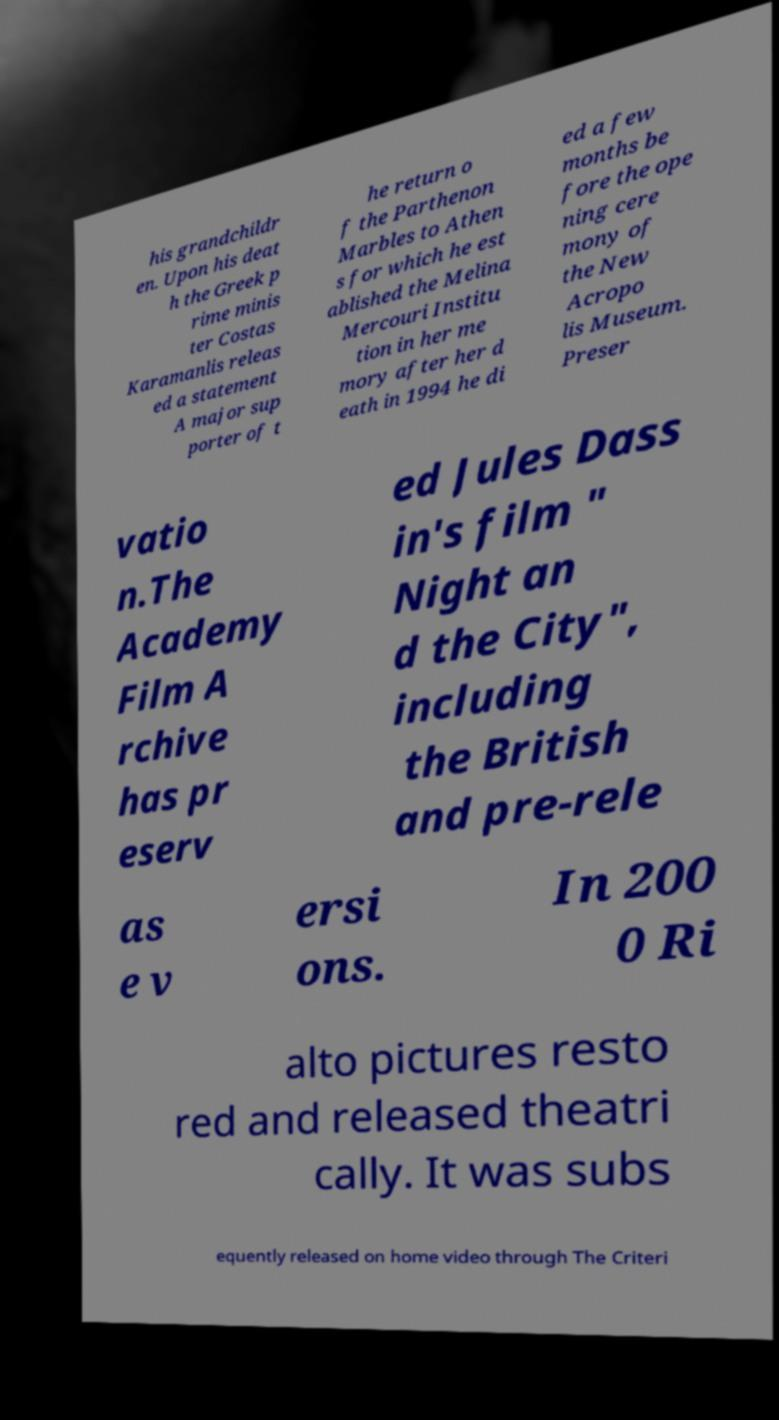Could you assist in decoding the text presented in this image and type it out clearly? his grandchildr en. Upon his deat h the Greek p rime minis ter Costas Karamanlis releas ed a statement A major sup porter of t he return o f the Parthenon Marbles to Athen s for which he est ablished the Melina Mercouri Institu tion in her me mory after her d eath in 1994 he di ed a few months be fore the ope ning cere mony of the New Acropo lis Museum. Preser vatio n.The Academy Film A rchive has pr eserv ed Jules Dass in's film " Night an d the City", including the British and pre-rele as e v ersi ons. In 200 0 Ri alto pictures resto red and released theatri cally. It was subs equently released on home video through The Criteri 